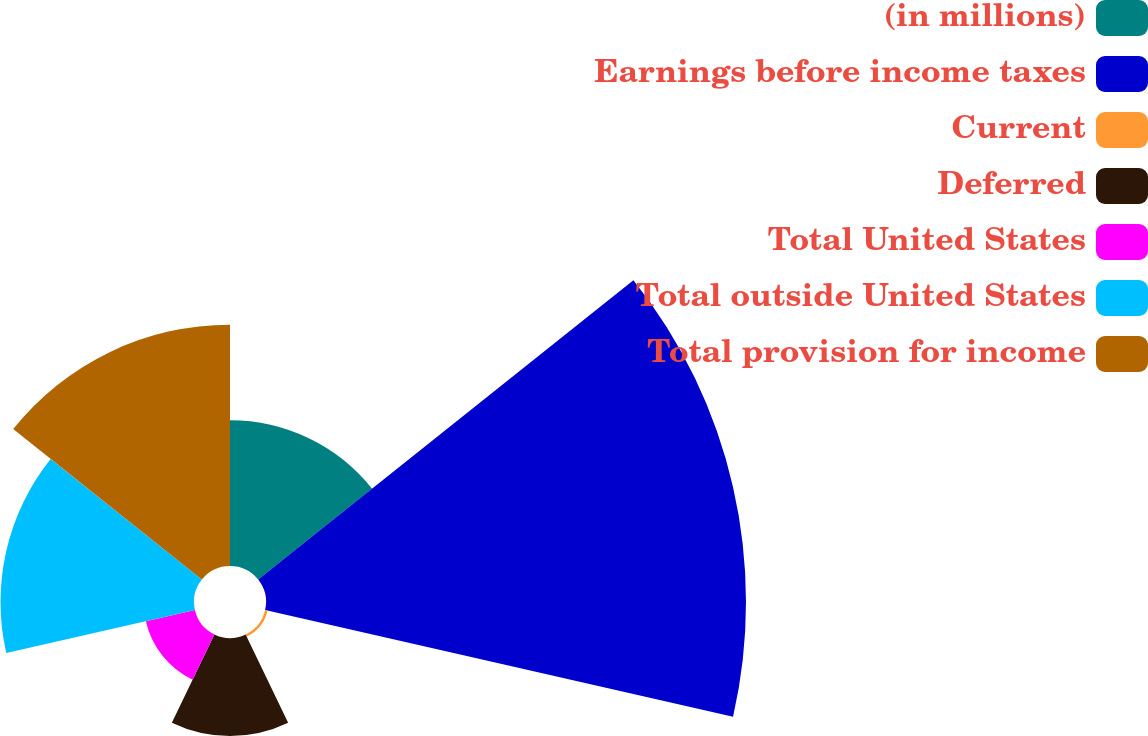Convert chart. <chart><loc_0><loc_0><loc_500><loc_500><pie_chart><fcel>(in millions)<fcel>Earnings before income taxes<fcel>Current<fcel>Deferred<fcel>Total United States<fcel>Total outside United States<fcel>Total provision for income<nl><fcel>12.03%<fcel>39.62%<fcel>0.21%<fcel>8.09%<fcel>4.15%<fcel>15.97%<fcel>19.92%<nl></chart> 